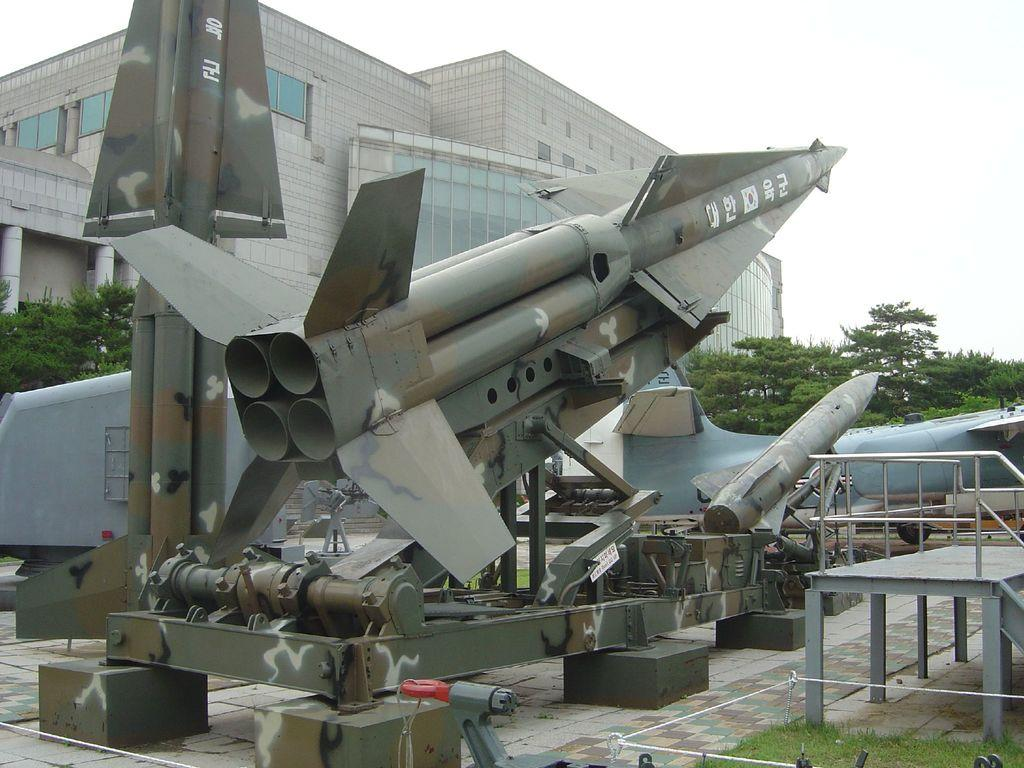What objects are on the ground in the image? There are missiles on the ground in the image. What structure is visible behind the missiles? There is a huge building behind the missiles. What type of vegetation is in front of the building? There are many trees in front of the building. What type of butter is being used to care for the trees in the image? There is no butter or any indication of tree care in the image; it features missiles on the ground and a huge building with trees in front. How does the sun affect the missiles in the image? The image does not show the sun or its effects on the missiles; it only shows the missiles on the ground and the surrounding environment. 